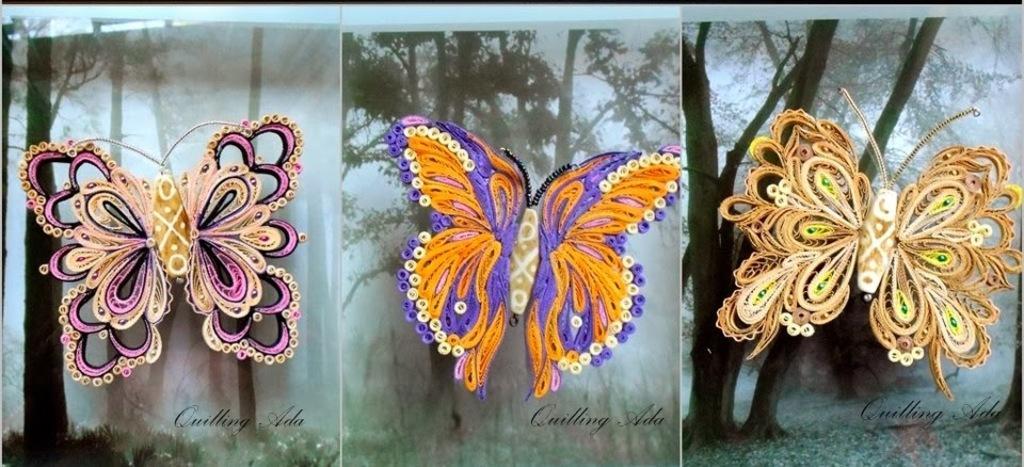Could you give a brief overview of what you see in this image? In this image it is a collage of three images. In the three images there are butterflies of different sizes and different colours. In the background there are trees. 